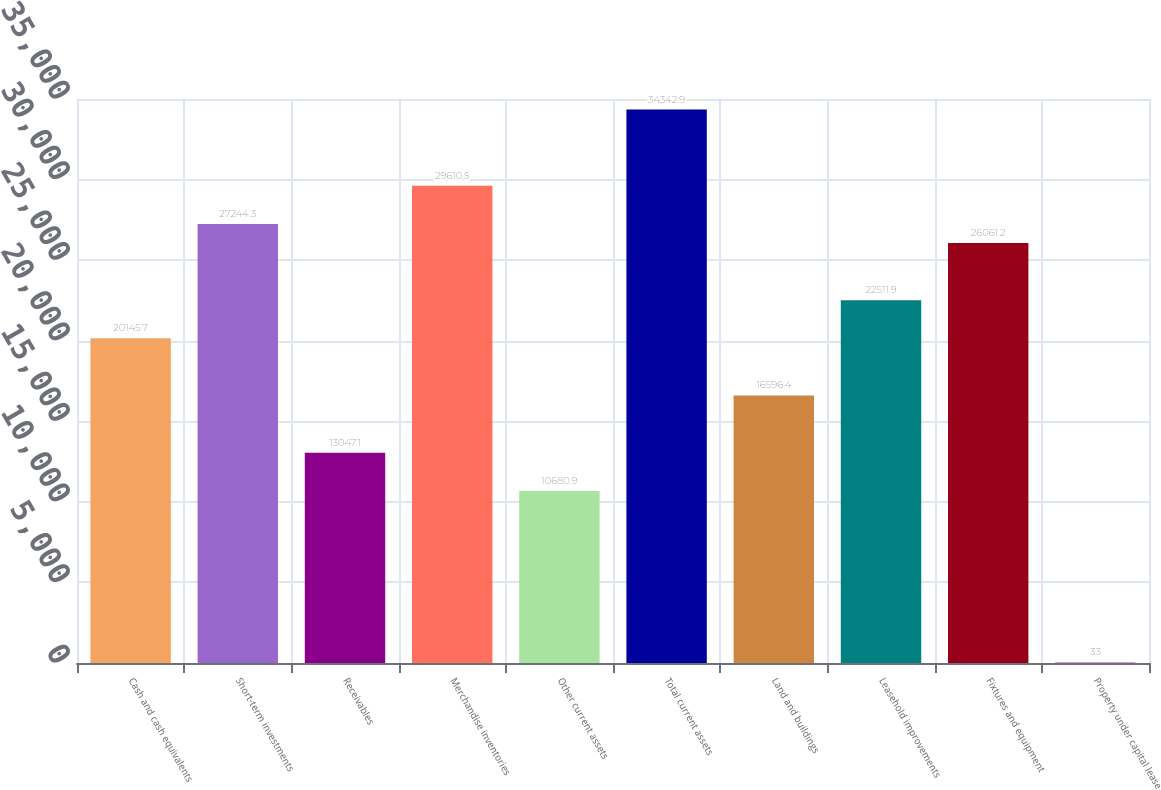Convert chart. <chart><loc_0><loc_0><loc_500><loc_500><bar_chart><fcel>Cash and cash equivalents<fcel>Short-term investments<fcel>Receivables<fcel>Merchandise inventories<fcel>Other current assets<fcel>Total current assets<fcel>Land and buildings<fcel>Leasehold improvements<fcel>Fixtures and equipment<fcel>Property under capital lease<nl><fcel>20145.7<fcel>27244.3<fcel>13047.1<fcel>29610.5<fcel>10680.9<fcel>34342.9<fcel>16596.4<fcel>22511.9<fcel>26061.2<fcel>33<nl></chart> 